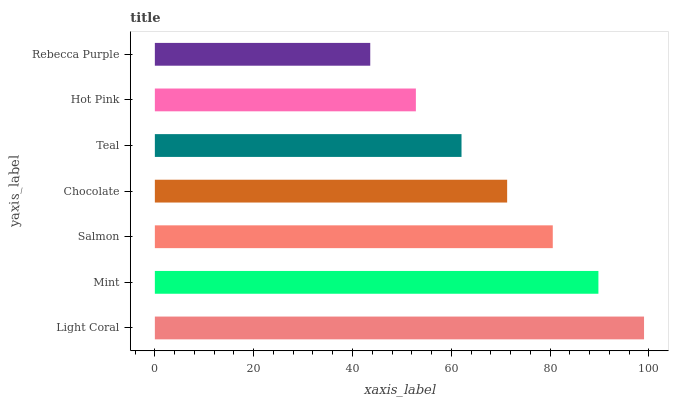Is Rebecca Purple the minimum?
Answer yes or no. Yes. Is Light Coral the maximum?
Answer yes or no. Yes. Is Mint the minimum?
Answer yes or no. No. Is Mint the maximum?
Answer yes or no. No. Is Light Coral greater than Mint?
Answer yes or no. Yes. Is Mint less than Light Coral?
Answer yes or no. Yes. Is Mint greater than Light Coral?
Answer yes or no. No. Is Light Coral less than Mint?
Answer yes or no. No. Is Chocolate the high median?
Answer yes or no. Yes. Is Chocolate the low median?
Answer yes or no. Yes. Is Salmon the high median?
Answer yes or no. No. Is Salmon the low median?
Answer yes or no. No. 